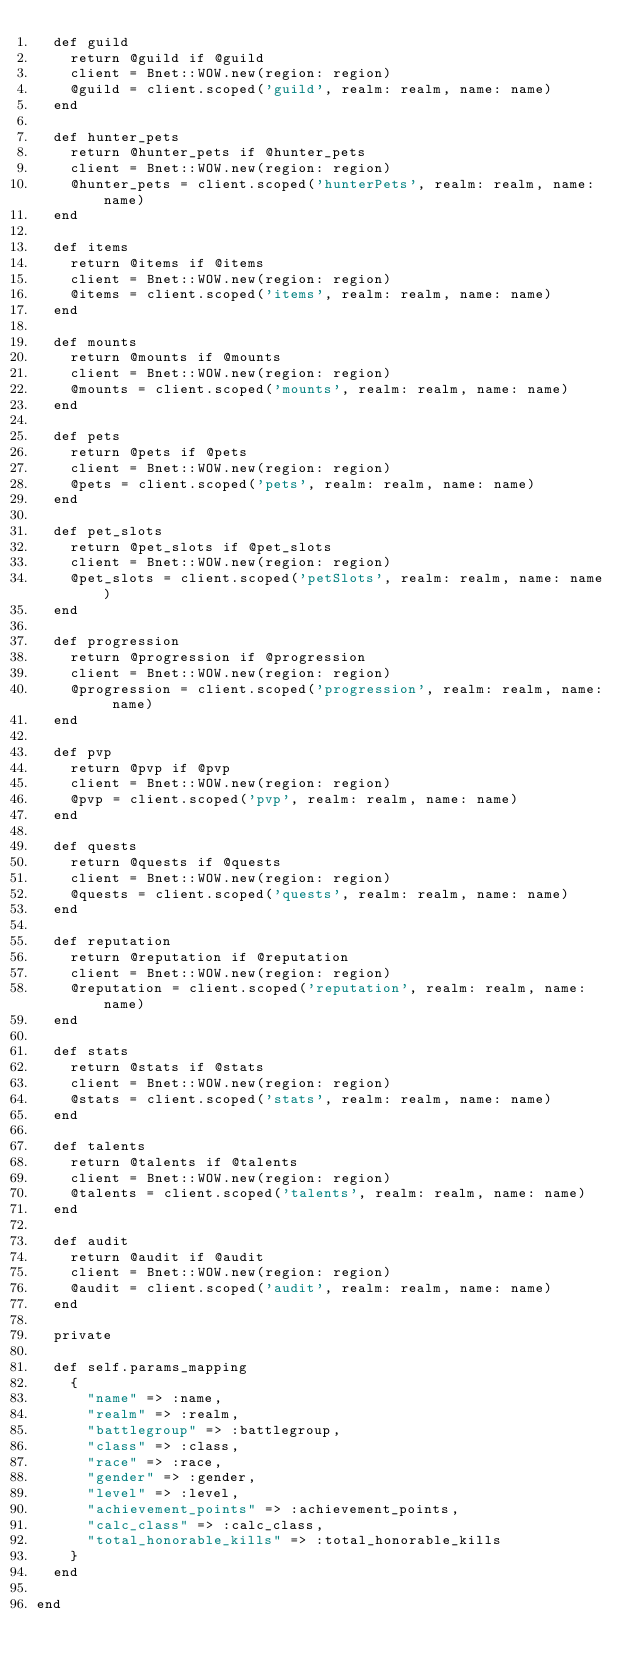<code> <loc_0><loc_0><loc_500><loc_500><_Ruby_>  def guild
    return @guild if @guild
    client = Bnet::WOW.new(region: region)
    @guild = client.scoped('guild', realm: realm, name: name)
  end

  def hunter_pets
    return @hunter_pets if @hunter_pets
    client = Bnet::WOW.new(region: region)
    @hunter_pets = client.scoped('hunterPets', realm: realm, name: name)
  end

  def items
    return @items if @items
    client = Bnet::WOW.new(region: region)
    @items = client.scoped('items', realm: realm, name: name)
  end

  def mounts
    return @mounts if @mounts
    client = Bnet::WOW.new(region: region)
    @mounts = client.scoped('mounts', realm: realm, name: name)
  end

  def pets
    return @pets if @pets
    client = Bnet::WOW.new(region: region)
    @pets = client.scoped('pets', realm: realm, name: name)
  end

  def pet_slots
    return @pet_slots if @pet_slots
    client = Bnet::WOW.new(region: region)
    @pet_slots = client.scoped('petSlots', realm: realm, name: name)
  end

  def progression
    return @progression if @progression
    client = Bnet::WOW.new(region: region)
    @progression = client.scoped('progression', realm: realm, name: name)
  end

  def pvp
    return @pvp if @pvp
    client = Bnet::WOW.new(region: region)
    @pvp = client.scoped('pvp', realm: realm, name: name)
  end

  def quests
    return @quests if @quests
    client = Bnet::WOW.new(region: region)
    @quests = client.scoped('quests', realm: realm, name: name)
  end

  def reputation
    return @reputation if @reputation
    client = Bnet::WOW.new(region: region)
    @reputation = client.scoped('reputation', realm: realm, name: name)
  end

  def stats
    return @stats if @stats
    client = Bnet::WOW.new(region: region)
    @stats = client.scoped('stats', realm: realm, name: name)
  end

  def talents
    return @talents if @talents
    client = Bnet::WOW.new(region: region)
    @talents = client.scoped('talents', realm: realm, name: name)
  end

  def audit
    return @audit if @audit
    client = Bnet::WOW.new(region: region)
    @audit = client.scoped('audit', realm: realm, name: name)
  end

  private

  def self.params_mapping
    {
      "name" => :name,
      "realm" => :realm,
      "battlegroup" => :battlegroup,
      "class" => :class,
      "race" => :race,
      "gender" => :gender,
      "level" => :level,
      "achievement_points" => :achievement_points,
      "calc_class" => :calc_class,
      "total_honorable_kills" => :total_honorable_kills
    }
  end

end
</code> 